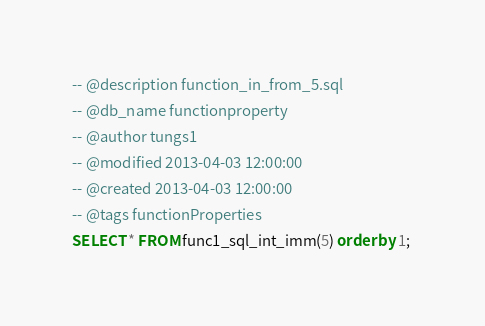<code> <loc_0><loc_0><loc_500><loc_500><_SQL_>-- @description function_in_from_5.sql
-- @db_name functionproperty
-- @author tungs1
-- @modified 2013-04-03 12:00:00
-- @created 2013-04-03 12:00:00
-- @tags functionProperties 
SELECT * FROM func1_sql_int_imm(5) order by 1; 
</code> 